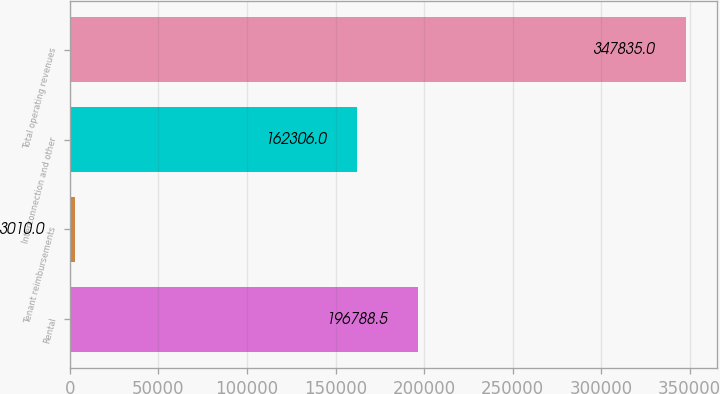Convert chart to OTSL. <chart><loc_0><loc_0><loc_500><loc_500><bar_chart><fcel>Rental<fcel>Tenant reimbursements<fcel>Interconnection and other<fcel>Total operating revenues<nl><fcel>196788<fcel>3010<fcel>162306<fcel>347835<nl></chart> 